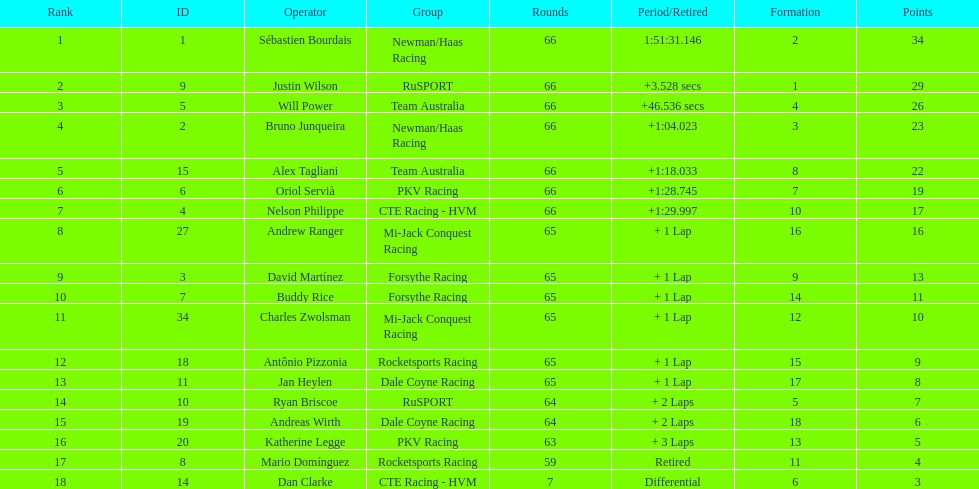Rice finished 10th. who finished next? Charles Zwolsman. 